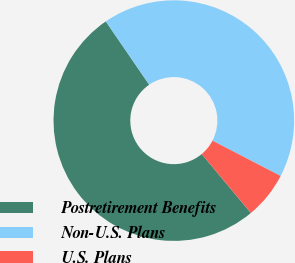<chart> <loc_0><loc_0><loc_500><loc_500><pie_chart><fcel>Postretirement Benefits<fcel>Non-U.S. Plans<fcel>U.S. Plans<nl><fcel>51.49%<fcel>42.18%<fcel>6.32%<nl></chart> 